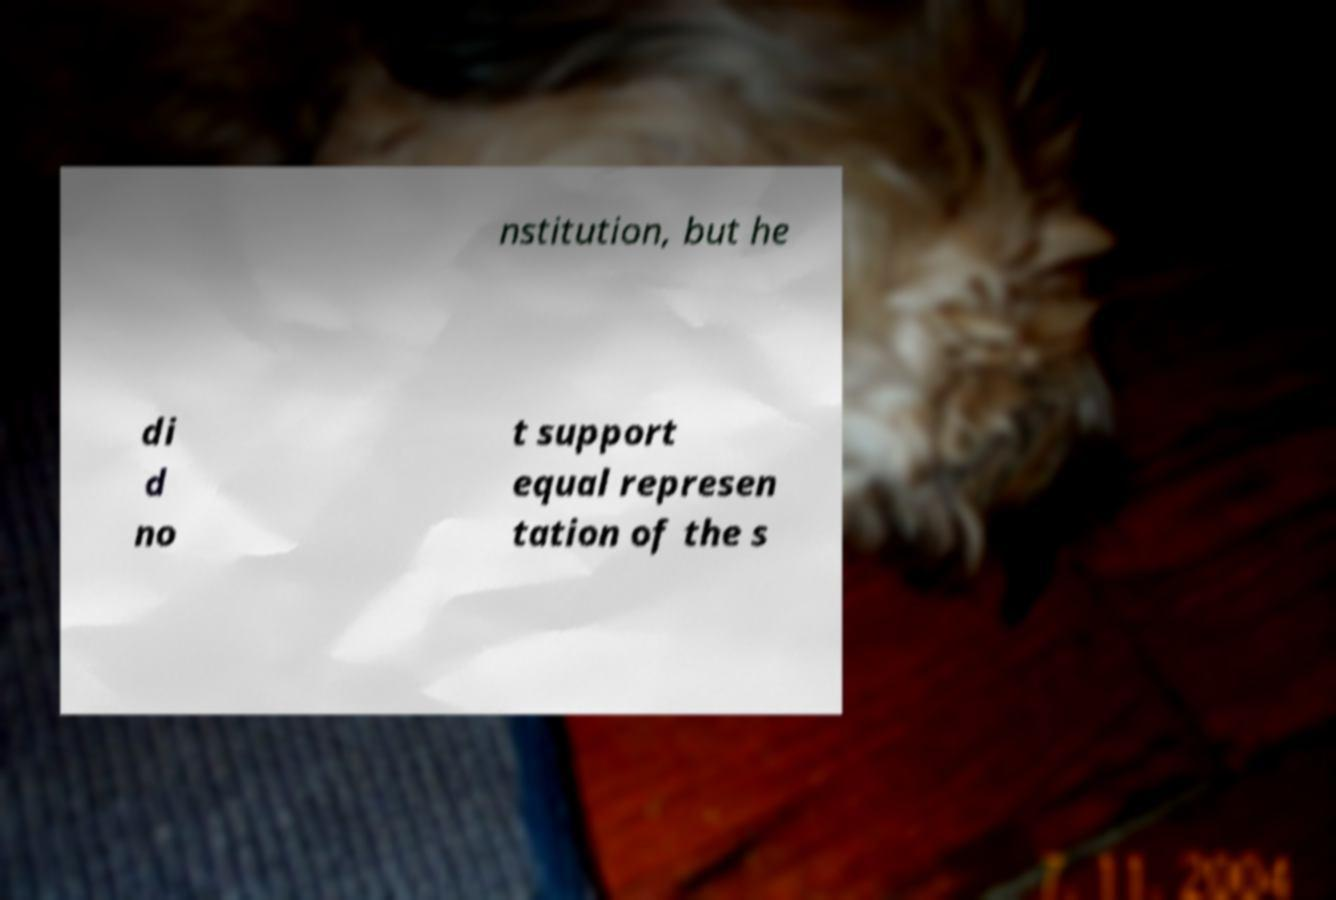What messages or text are displayed in this image? I need them in a readable, typed format. nstitution, but he di d no t support equal represen tation of the s 